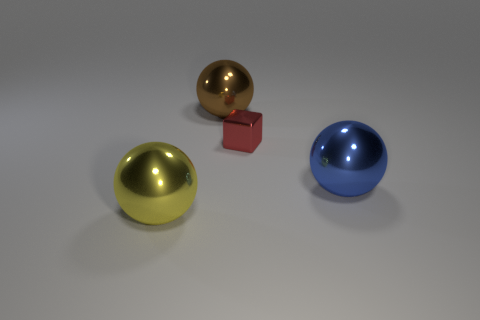Is the shape of the big yellow metal thing the same as the shiny object behind the tiny metal object?
Your answer should be compact. Yes. Is the shape of the tiny red object the same as the yellow thing?
Make the answer very short. No. How many brown objects are either tiny metallic things or metallic objects?
Ensure brevity in your answer.  1. Is there any other thing that has the same size as the block?
Your answer should be compact. No. What number of large things are yellow cubes or brown balls?
Provide a short and direct response. 1. Are there fewer brown objects than small blue shiny cylinders?
Provide a succinct answer. No. Is there any other thing that has the same shape as the tiny object?
Provide a short and direct response. No. Is the number of big red metallic objects greater than the number of large brown metal objects?
Provide a short and direct response. No. How many other objects are the same material as the big blue object?
Provide a succinct answer. 3. The thing behind the small cube that is to the left of the shiny thing that is on the right side of the red shiny object is what shape?
Your answer should be very brief. Sphere. 